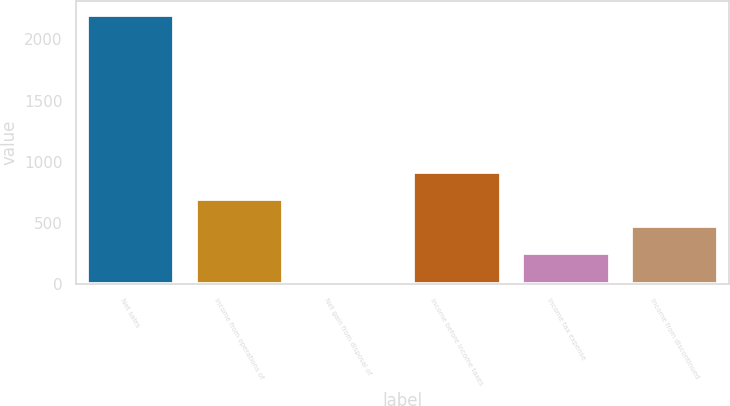Convert chart to OTSL. <chart><loc_0><loc_0><loc_500><loc_500><bar_chart><fcel>Net sales<fcel>Income from operations of<fcel>Net gain from disposal of<fcel>Income before income taxes<fcel>Income tax expense<fcel>Income from discontinued<nl><fcel>2203<fcel>696.1<fcel>7<fcel>915.7<fcel>256.9<fcel>476.5<nl></chart> 